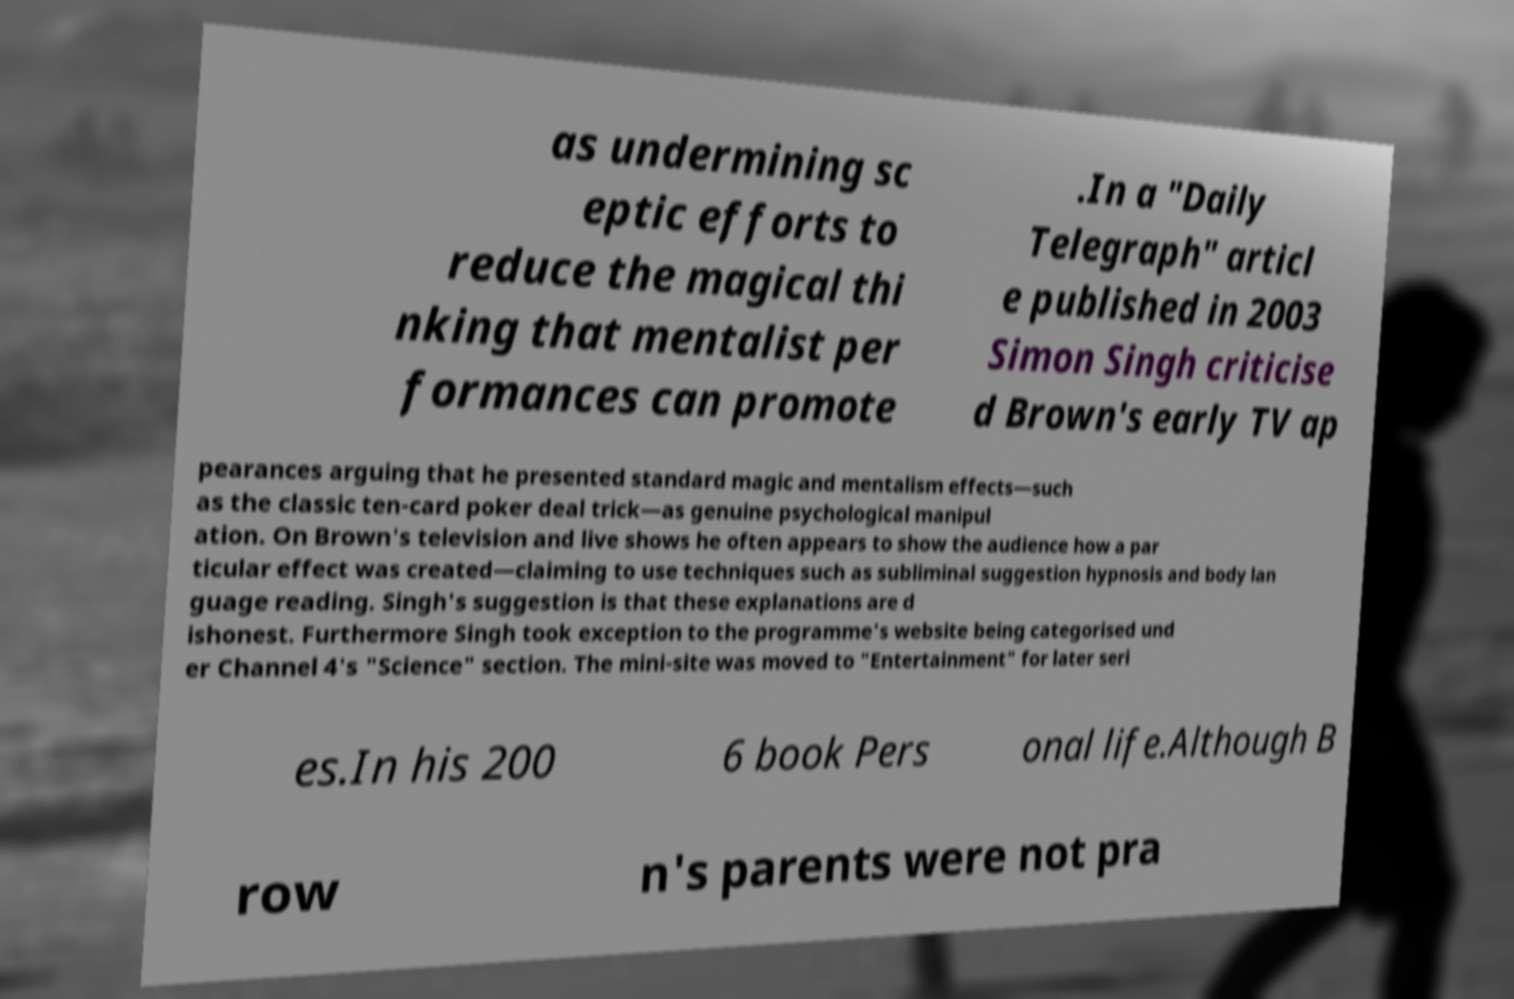I need the written content from this picture converted into text. Can you do that? as undermining sc eptic efforts to reduce the magical thi nking that mentalist per formances can promote .In a "Daily Telegraph" articl e published in 2003 Simon Singh criticise d Brown's early TV ap pearances arguing that he presented standard magic and mentalism effects—such as the classic ten-card poker deal trick—as genuine psychological manipul ation. On Brown's television and live shows he often appears to show the audience how a par ticular effect was created—claiming to use techniques such as subliminal suggestion hypnosis and body lan guage reading. Singh's suggestion is that these explanations are d ishonest. Furthermore Singh took exception to the programme's website being categorised und er Channel 4's "Science" section. The mini-site was moved to "Entertainment" for later seri es.In his 200 6 book Pers onal life.Although B row n's parents were not pra 